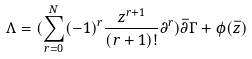<formula> <loc_0><loc_0><loc_500><loc_500>\Lambda = ( \sum _ { r = 0 } ^ { N } ( - 1 ) ^ { r } \frac { z ^ { r + 1 } } { ( r + 1 ) ! } \partial ^ { r } ) \bar { \partial } \Gamma + \phi ( \bar { z } )</formula> 